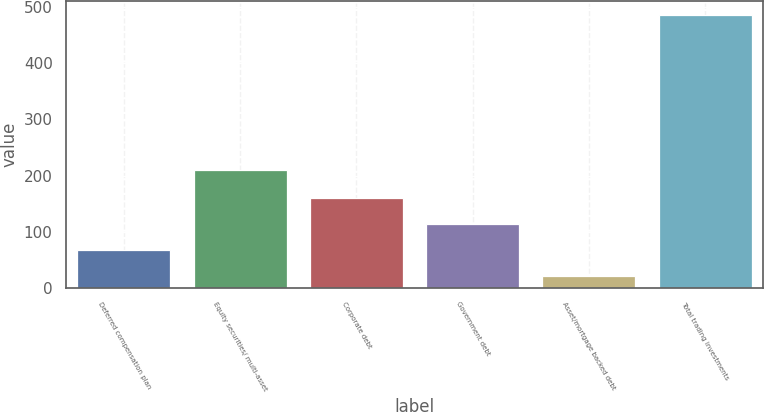<chart> <loc_0><loc_0><loc_500><loc_500><bar_chart><fcel>Deferred compensation plan<fcel>Equity securities/ multi-asset<fcel>Corporate debt<fcel>Government debt<fcel>Asset/mortgage backed debt<fcel>Total trading investments<nl><fcel>66.7<fcel>210<fcel>160.1<fcel>113.4<fcel>20<fcel>487<nl></chart> 